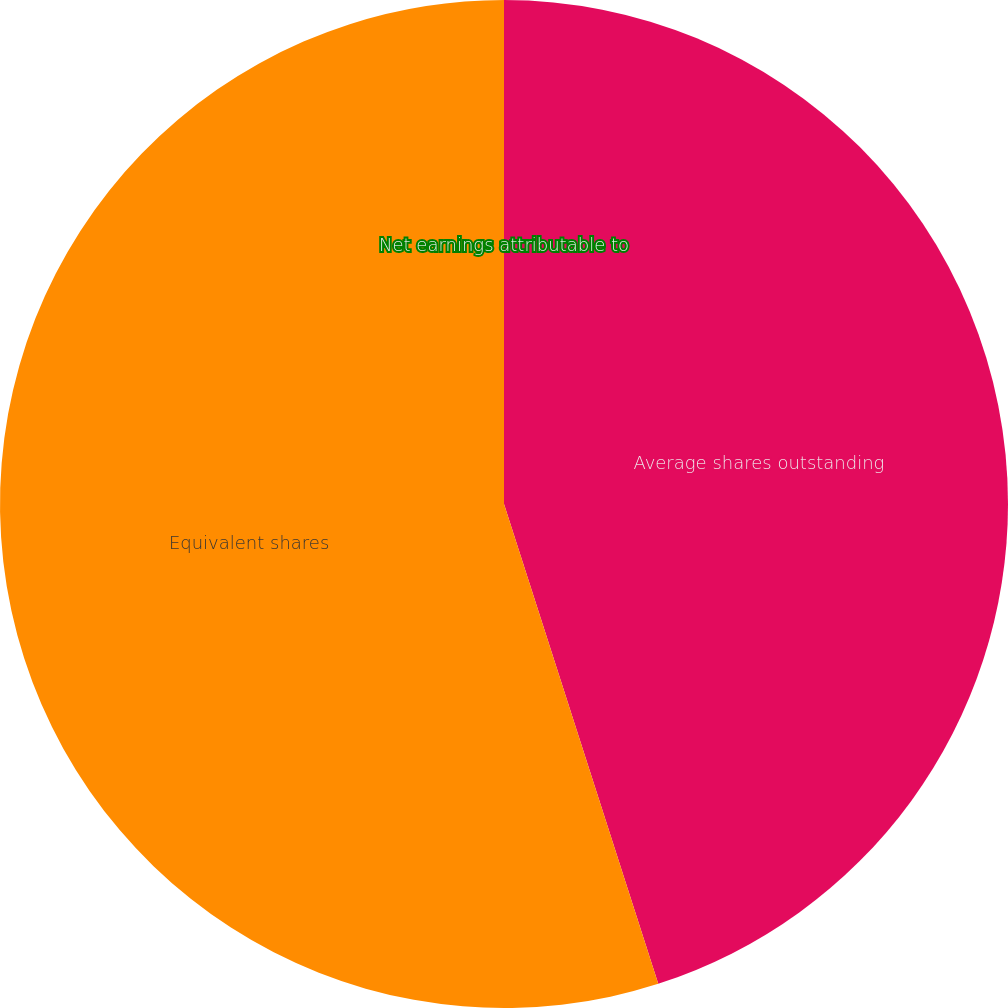Convert chart. <chart><loc_0><loc_0><loc_500><loc_500><pie_chart><fcel>Net earnings attributable to<fcel>Average shares outstanding<fcel>Equivalent shares<nl><fcel>0.0%<fcel>45.05%<fcel>54.95%<nl></chart> 